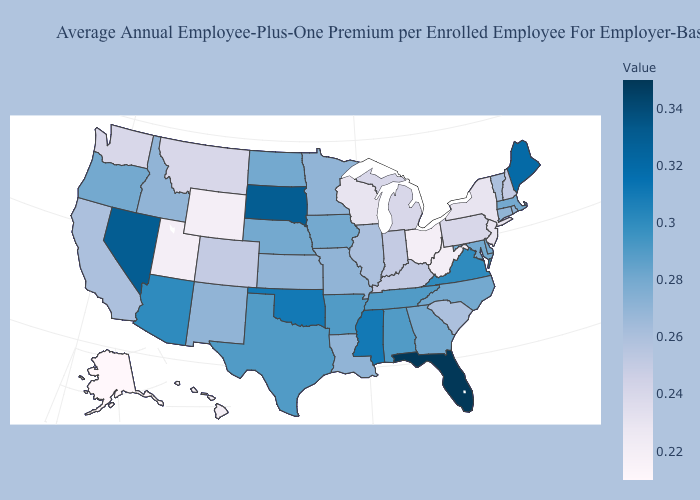Is the legend a continuous bar?
Answer briefly. Yes. Which states have the highest value in the USA?
Concise answer only. Florida. 